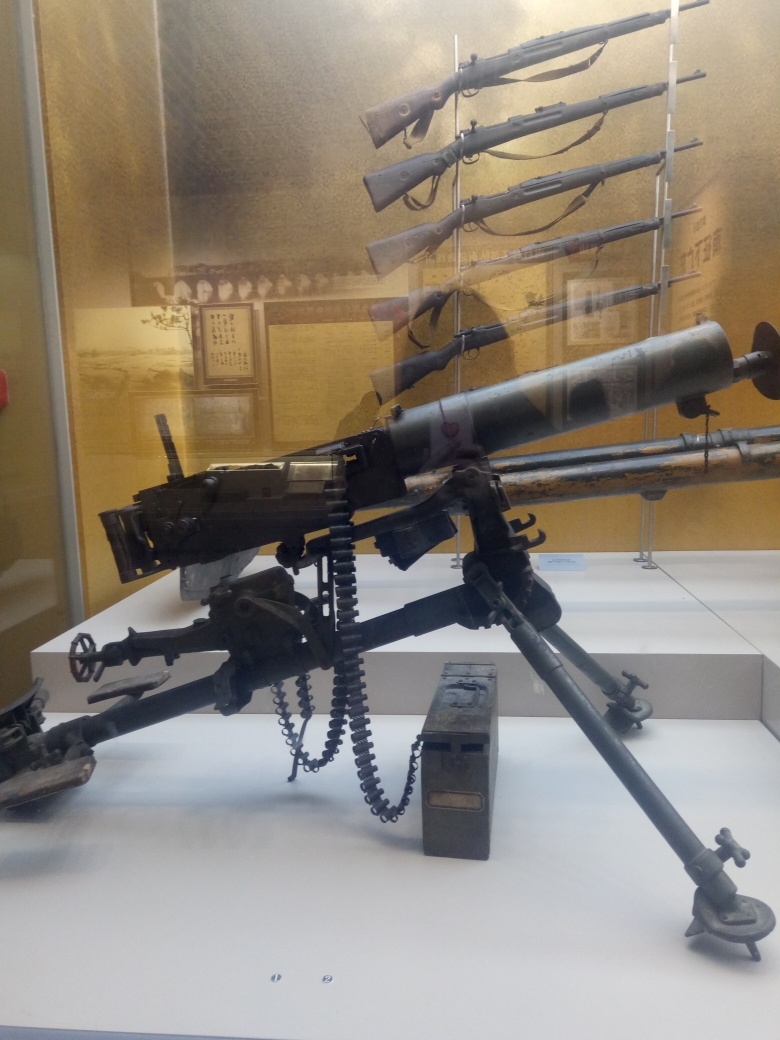Is the main subject, firearms on display, clear?
A. No
B. Yes
Answer with the option's letter from the given choices directly.
 B. 